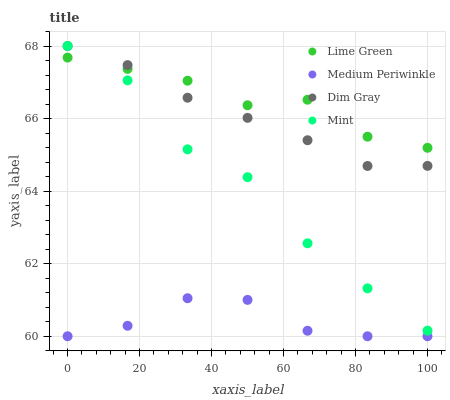Does Medium Periwinkle have the minimum area under the curve?
Answer yes or no. Yes. Does Lime Green have the maximum area under the curve?
Answer yes or no. Yes. Does Dim Gray have the minimum area under the curve?
Answer yes or no. No. Does Dim Gray have the maximum area under the curve?
Answer yes or no. No. Is Dim Gray the smoothest?
Answer yes or no. Yes. Is Mint the roughest?
Answer yes or no. Yes. Is Lime Green the smoothest?
Answer yes or no. No. Is Lime Green the roughest?
Answer yes or no. No. Does Medium Periwinkle have the lowest value?
Answer yes or no. Yes. Does Dim Gray have the lowest value?
Answer yes or no. No. Does Mint have the highest value?
Answer yes or no. Yes. Does Lime Green have the highest value?
Answer yes or no. No. Is Medium Periwinkle less than Dim Gray?
Answer yes or no. Yes. Is Dim Gray greater than Medium Periwinkle?
Answer yes or no. Yes. Does Dim Gray intersect Lime Green?
Answer yes or no. Yes. Is Dim Gray less than Lime Green?
Answer yes or no. No. Is Dim Gray greater than Lime Green?
Answer yes or no. No. Does Medium Periwinkle intersect Dim Gray?
Answer yes or no. No. 